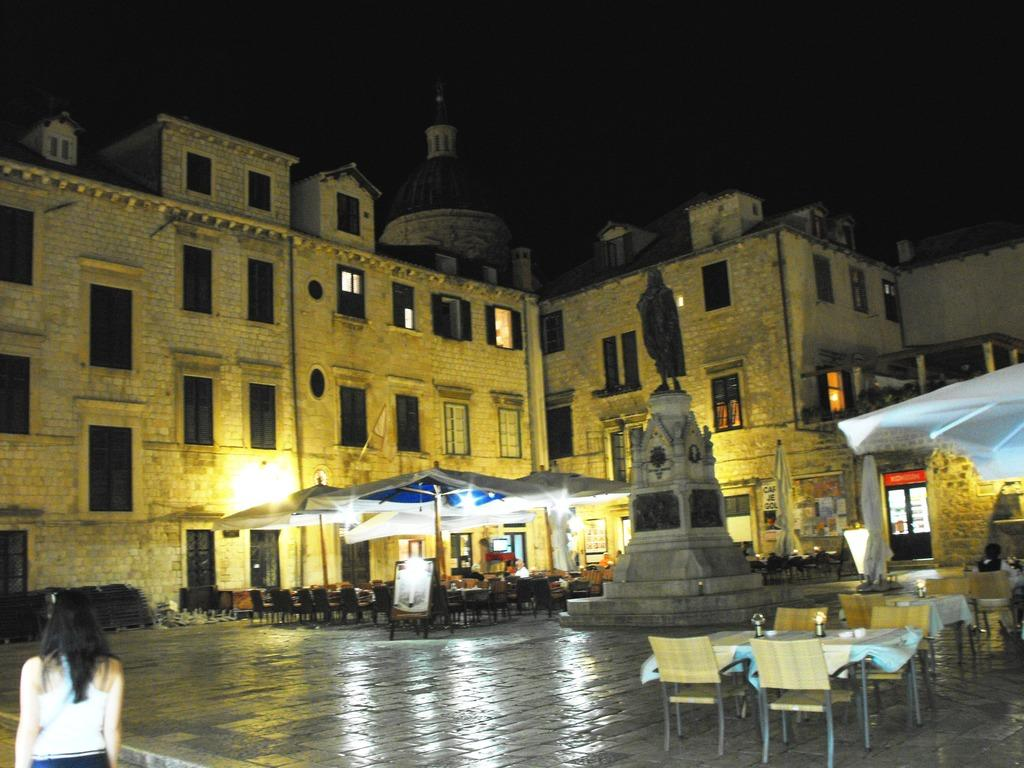What type of structure is present in the image? There is a building in the image. Can you describe the surroundings of the building? There is another building near the first building, and there are tables and chairs in the image. What additional feature can be seen near the building? There is a statue near the building. What is happening in the image involving a person? A woman is walking on the road in the image. What degree does the woman walking on the road have in the image? There is no information about the woman's degree in the image. How many friends is the woman walking on the road with in the image? There is no indication of friends in the image; the woman is walking alone. 